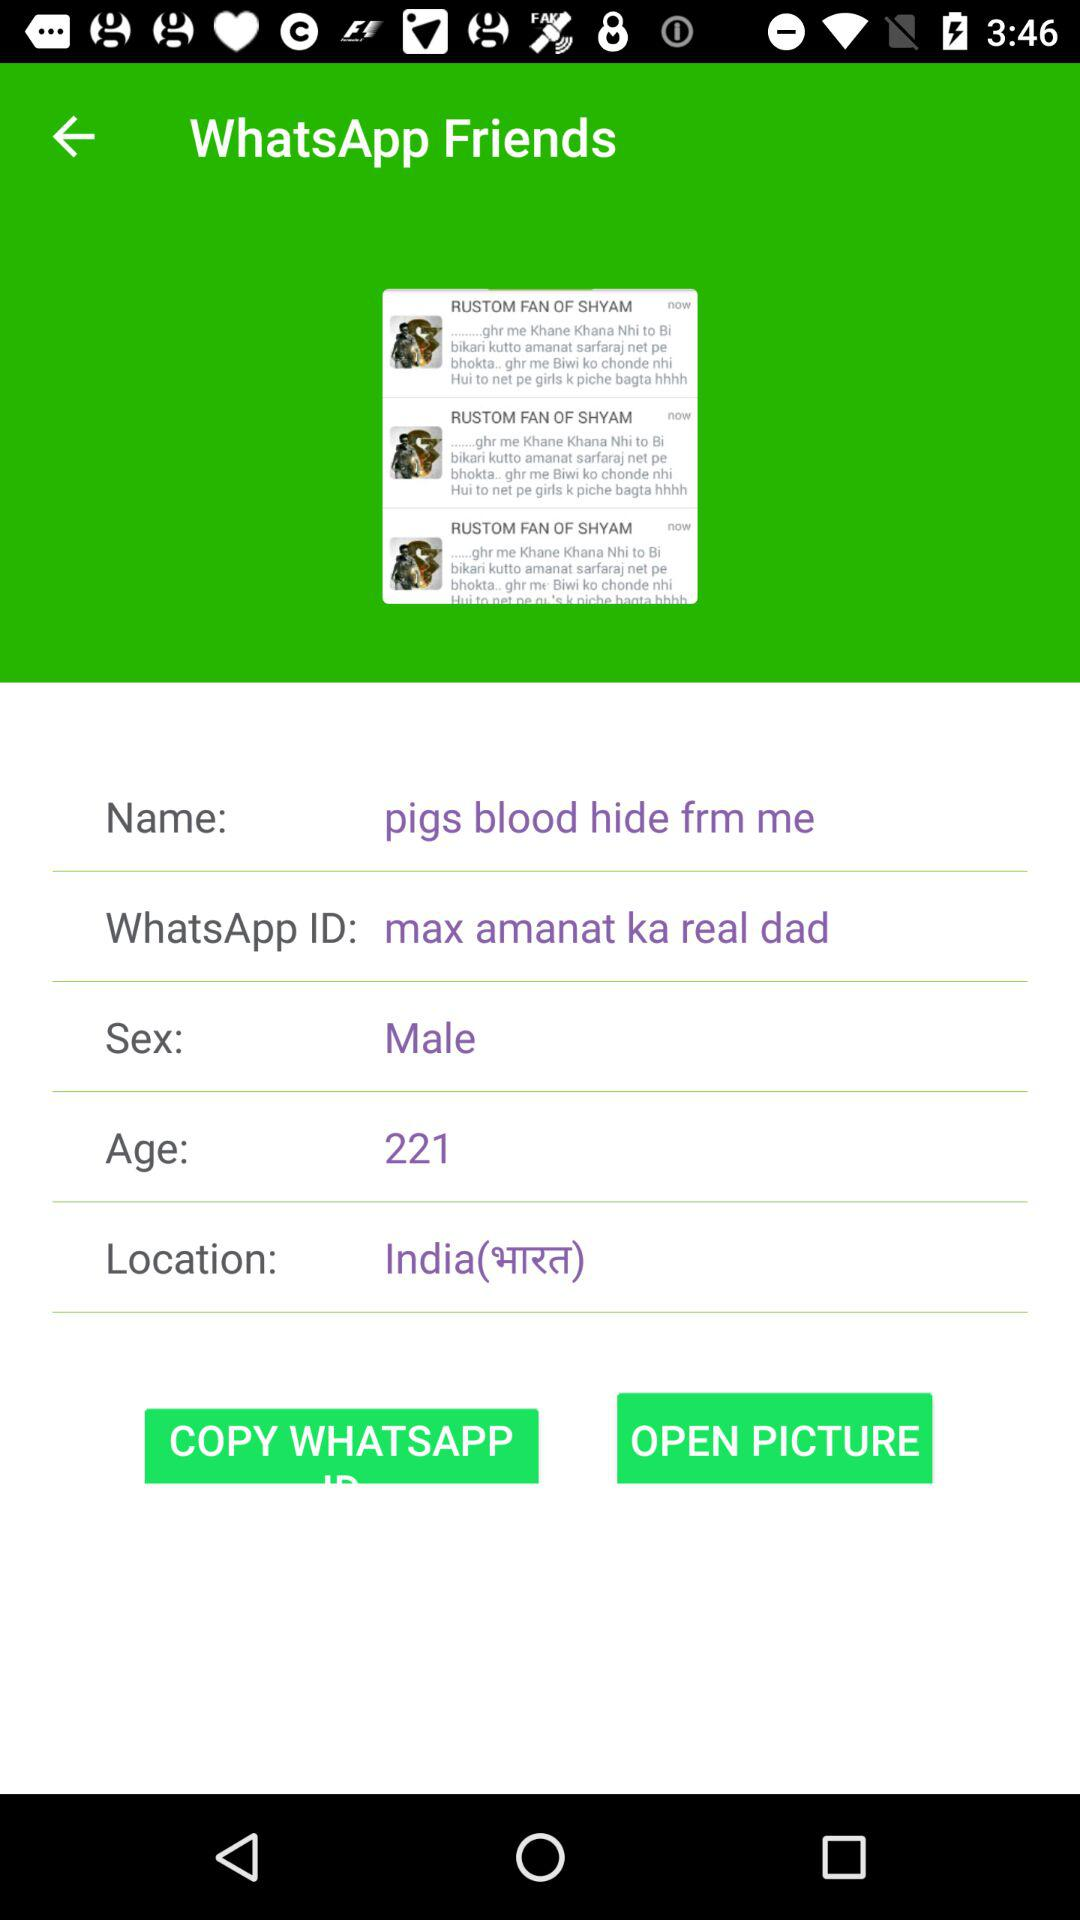What is the given age? The given age is 221. 